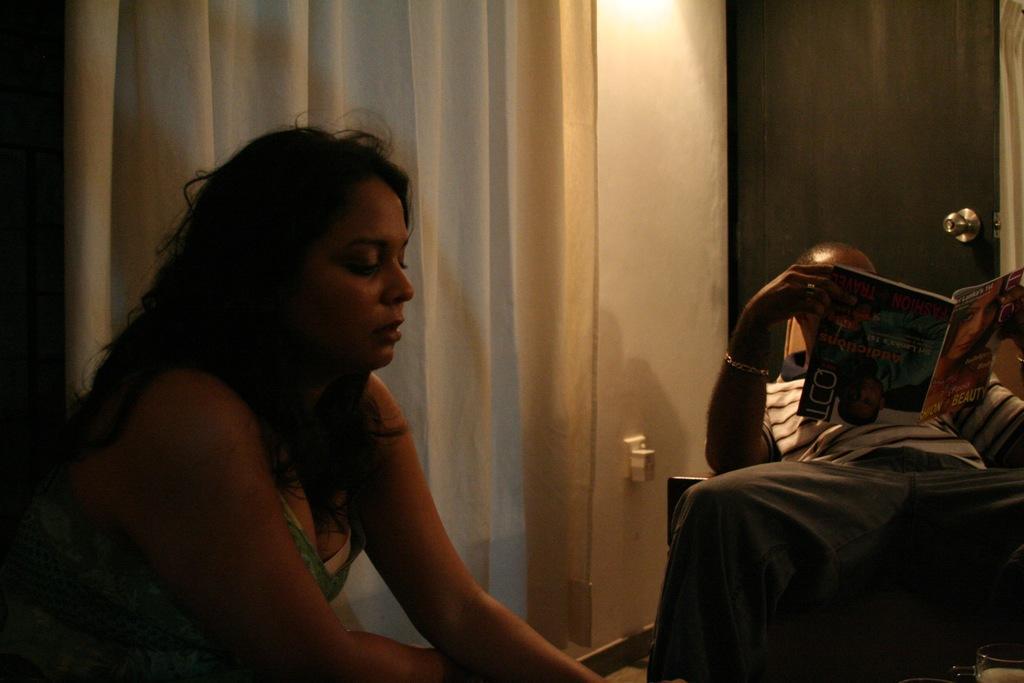Please provide a concise description of this image. In this picture we can see a man holding a book with his hands and in front of him we can see a woman and in the background we can see a door, curtain, wall, some objects. 